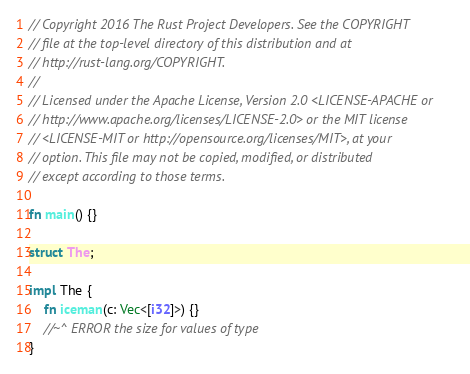<code> <loc_0><loc_0><loc_500><loc_500><_Rust_>// Copyright 2016 The Rust Project Developers. See the COPYRIGHT
// file at the top-level directory of this distribution and at
// http://rust-lang.org/COPYRIGHT.
//
// Licensed under the Apache License, Version 2.0 <LICENSE-APACHE or
// http://www.apache.org/licenses/LICENSE-2.0> or the MIT license
// <LICENSE-MIT or http://opensource.org/licenses/MIT>, at your
// option. This file may not be copied, modified, or distributed
// except according to those terms.

fn main() {}

struct The;

impl The {
    fn iceman(c: Vec<[i32]>) {}
    //~^ ERROR the size for values of type
}
</code> 